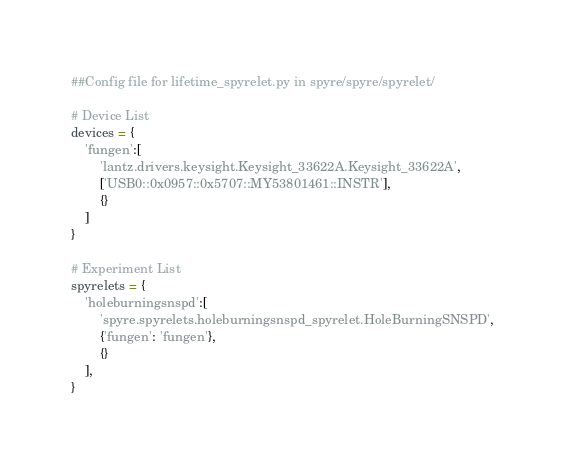Convert code to text. <code><loc_0><loc_0><loc_500><loc_500><_Python_>##Config file for lifetime_spyrelet.py in spyre/spyre/spyrelet/

# Device List
devices = {
    'fungen':[
        'lantz.drivers.keysight.Keysight_33622A.Keysight_33622A',
        ['USB0::0x0957::0x5707::MY53801461::INSTR'],
        {}
    ]
}

# Experiment List
spyrelets = {
    'holeburningsnspd':[
        'spyre.spyrelets.holeburningsnspd_spyrelet.HoleBurningSNSPD',
        {'fungen': 'fungen'}, 
        {}
    ],
}</code> 